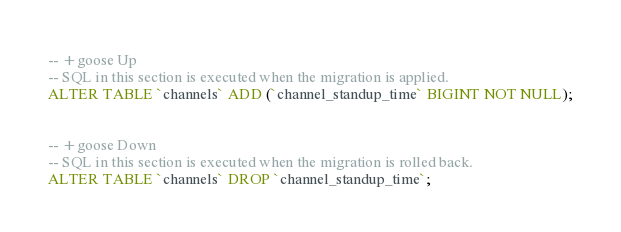<code> <loc_0><loc_0><loc_500><loc_500><_SQL_>-- +goose Up
-- SQL in this section is executed when the migration is applied.
ALTER TABLE `channels` ADD (`channel_standup_time` BIGINT NOT NULL);


-- +goose Down
-- SQL in this section is executed when the migration is rolled back.
ALTER TABLE `channels` DROP `channel_standup_time`;</code> 